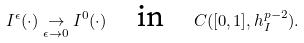Convert formula to latex. <formula><loc_0><loc_0><loc_500><loc_500>I ^ { \epsilon } ( \cdot ) \underset { \epsilon \to 0 } \rightarrow I ^ { 0 } ( \cdot ) \quad \text {in} \quad C ( [ 0 , 1 ] , h ^ { p - 2 } _ { I } ) .</formula> 